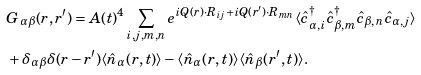Convert formula to latex. <formula><loc_0><loc_0><loc_500><loc_500>& G _ { \alpha \beta } ( { r } , { r ^ { \prime } } ) = A ( t ) ^ { 4 } \sum _ { i , j , m , n } e ^ { i Q ( { r } ) \cdot { R } _ { i j } + i Q ( { r ^ { \prime } } ) \cdot { R } _ { m n } } \langle \hat { c } _ { \alpha , i } ^ { \dagger } \hat { c } _ { \beta , m } ^ { \dagger } \hat { c } _ { \beta , n } \hat { c } _ { \alpha , j } \rangle \\ & + \delta _ { \alpha \beta } \delta ( { r } - { r ^ { \prime } } ) \langle \hat { n } _ { \alpha } ( { r } , t ) \rangle - \langle \hat { n } _ { \alpha } ( { r } , t ) \rangle \langle \hat { n } _ { \beta } ( { r ^ { \prime } } , t ) \rangle .</formula> 